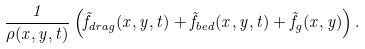Convert formula to latex. <formula><loc_0><loc_0><loc_500><loc_500>\frac { 1 } { \rho ( x , y , t ) } \left ( \vec { f } _ { d r a g } ( x , y , t ) + \vec { f } _ { b e d } ( x , y , t ) + \vec { f } _ { g } ( x , y ) \right ) .</formula> 